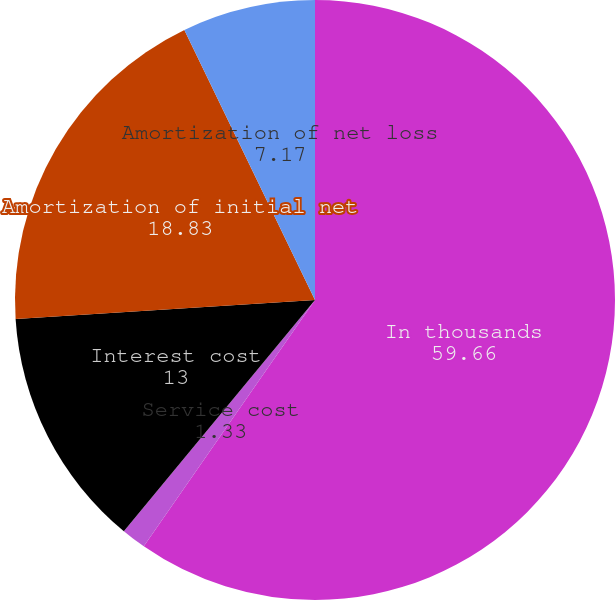<chart> <loc_0><loc_0><loc_500><loc_500><pie_chart><fcel>In thousands<fcel>Service cost<fcel>Interest cost<fcel>Amortization of initial net<fcel>Amortization of net loss<nl><fcel>59.66%<fcel>1.33%<fcel>13.0%<fcel>18.83%<fcel>7.17%<nl></chart> 